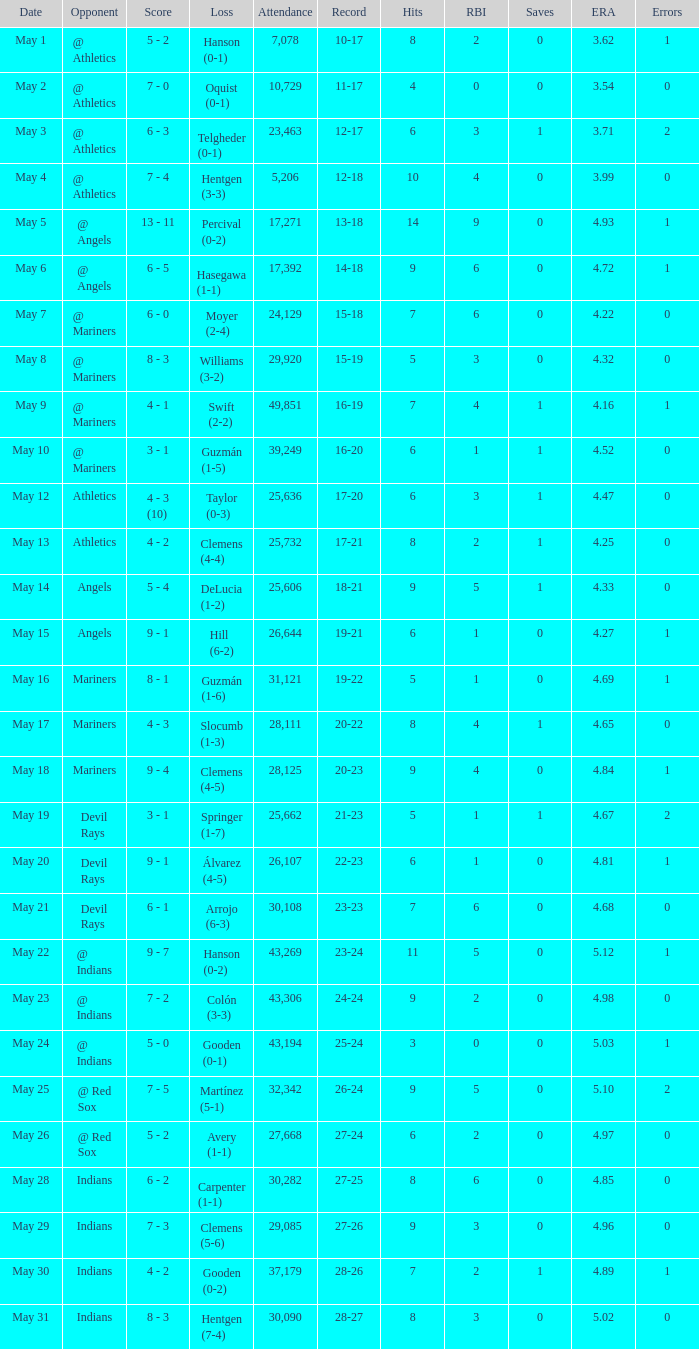Who was defeated on may 31? Hentgen (7-4). 